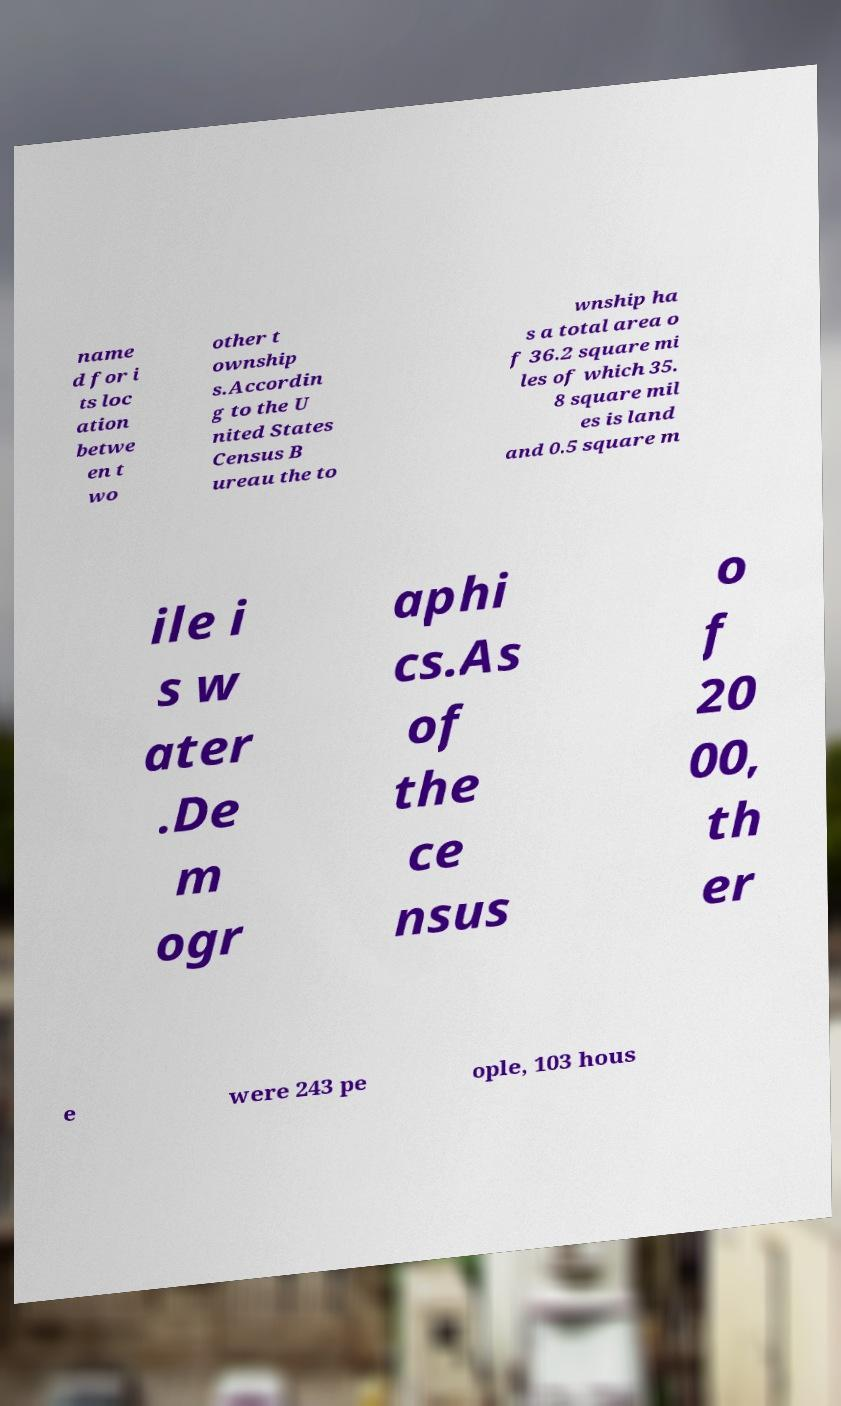I need the written content from this picture converted into text. Can you do that? name d for i ts loc ation betwe en t wo other t ownship s.Accordin g to the U nited States Census B ureau the to wnship ha s a total area o f 36.2 square mi les of which 35. 8 square mil es is land and 0.5 square m ile i s w ater .De m ogr aphi cs.As of the ce nsus o f 20 00, th er e were 243 pe ople, 103 hous 